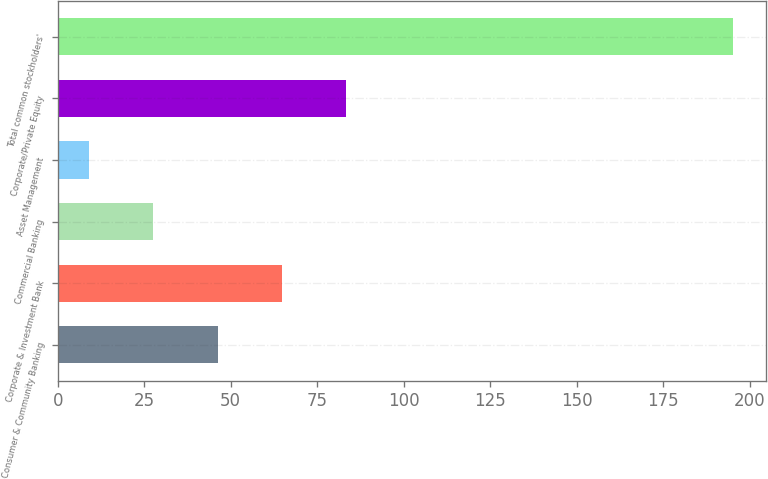Convert chart. <chart><loc_0><loc_0><loc_500><loc_500><bar_chart><fcel>Consumer & Community Banking<fcel>Corporate & Investment Bank<fcel>Commercial Banking<fcel>Asset Management<fcel>Corporate/Private Equity<fcel>Total common stockholders'<nl><fcel>46.2<fcel>64.8<fcel>27.6<fcel>9<fcel>83.4<fcel>195<nl></chart> 